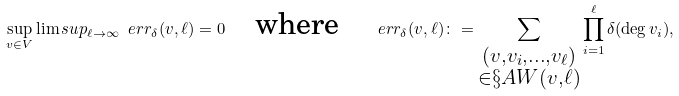Convert formula to latex. <formula><loc_0><loc_0><loc_500><loc_500>\sup _ { v \in V } \lim s u p _ { \ell \to \infty } \ e r r _ { \delta } ( v , \ell ) = 0 \quad \text {where} \quad \ e r r _ { \delta } ( v , \ell ) \colon = \sum _ { \substack { ( v , v _ { i } , \dots , v _ { \ell } ) \\ \in \S A W ( v , \ell ) } } \prod _ { i = 1 } ^ { \ell } \delta ( \deg { v _ { i } } ) ,</formula> 